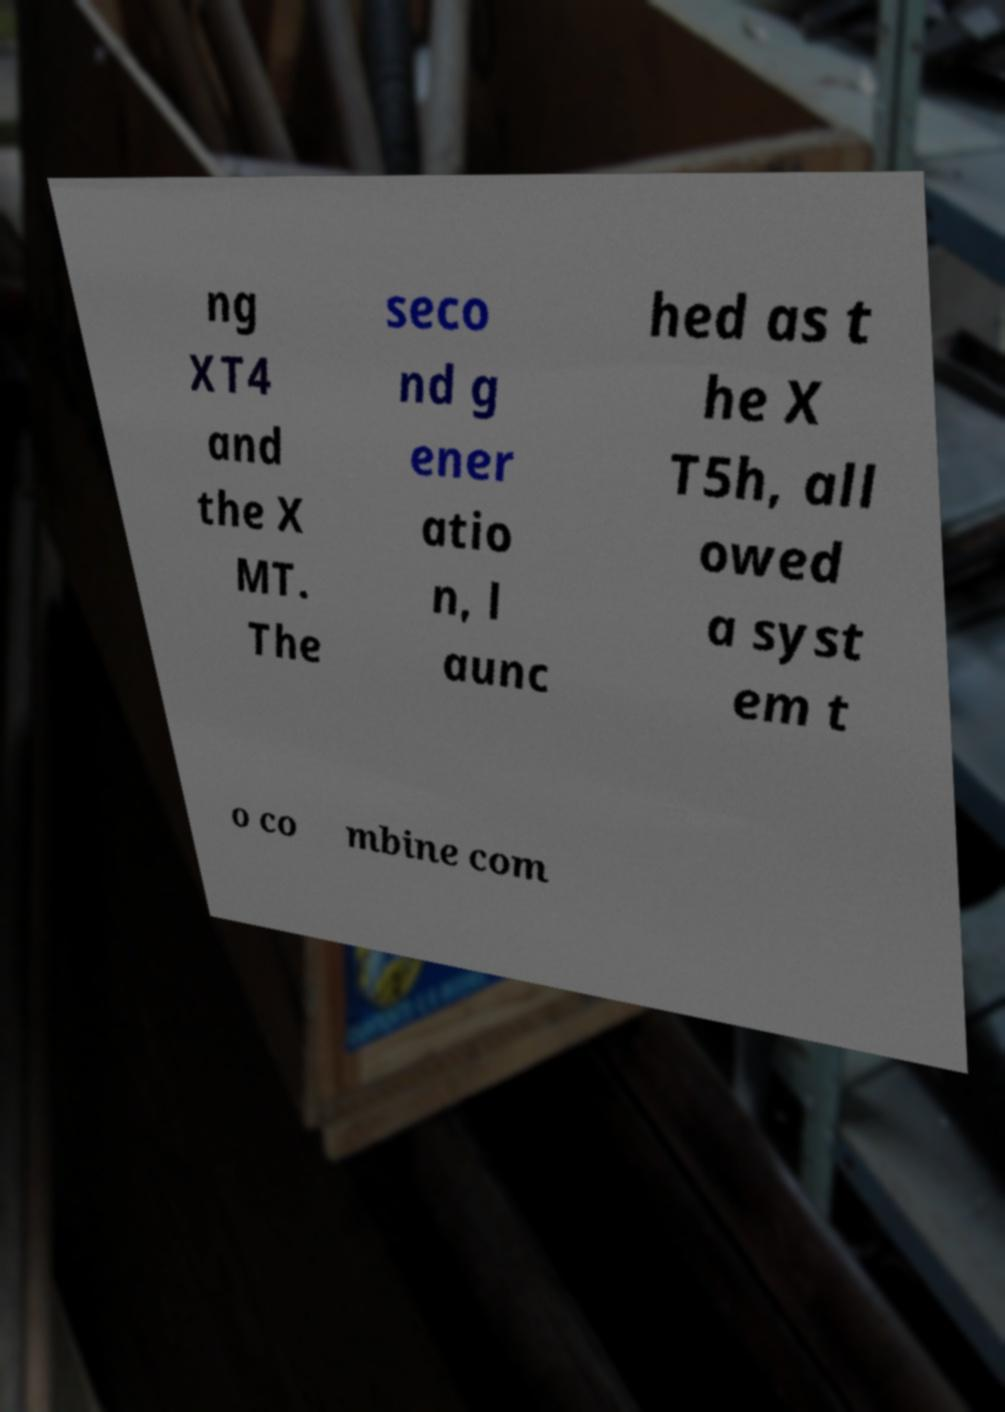Can you accurately transcribe the text from the provided image for me? ng XT4 and the X MT. The seco nd g ener atio n, l aunc hed as t he X T5h, all owed a syst em t o co mbine com 